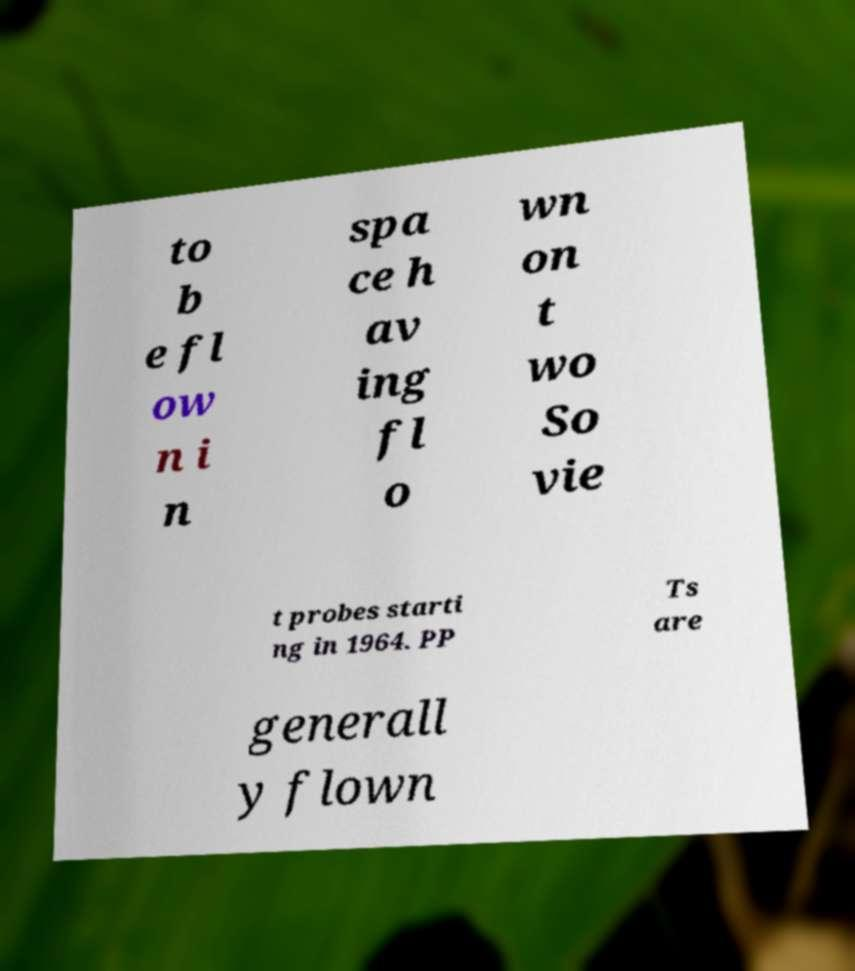Please identify and transcribe the text found in this image. to b e fl ow n i n spa ce h av ing fl o wn on t wo So vie t probes starti ng in 1964. PP Ts are generall y flown 